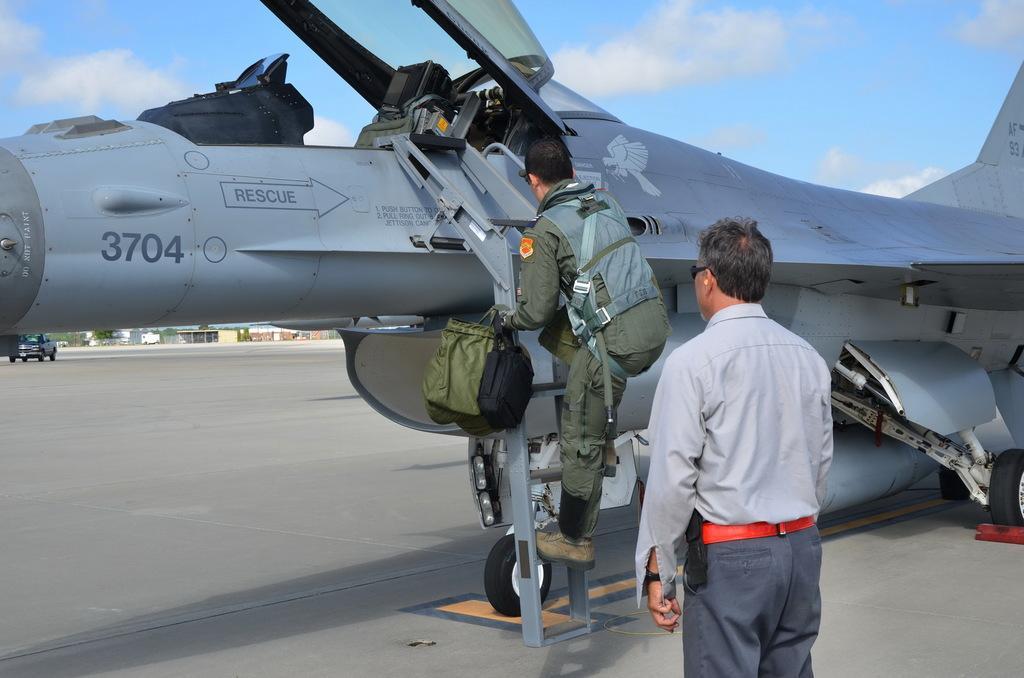In one or two sentences, can you explain what this image depicts? At the center of the image there is an air force. One person is climbing the stairs of an air force, in front of this person there is another person standing. In the background there is a sky. 